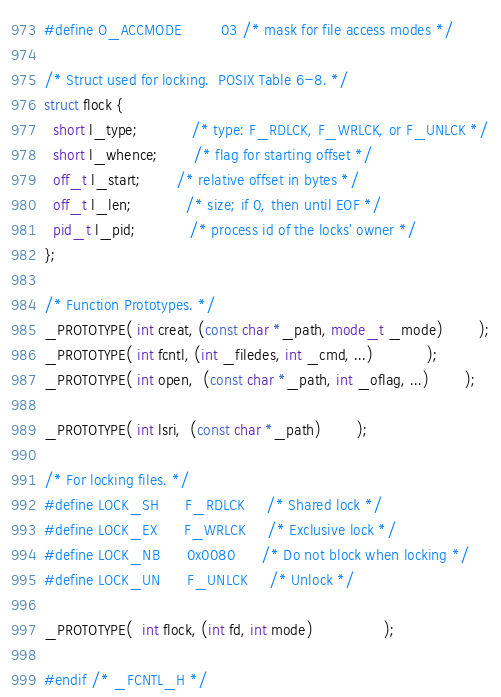Convert code to text. <code><loc_0><loc_0><loc_500><loc_500><_C_>#define O_ACCMODE         03	/* mask for file access modes */

/* Struct used for locking.  POSIX Table 6-8. */
struct flock {
  short l_type;			/* type: F_RDLCK, F_WRLCK, or F_UNLCK */
  short l_whence;		/* flag for starting offset */
  off_t l_start;		/* relative offset in bytes */
  off_t l_len;			/* size; if 0, then until EOF */
  pid_t l_pid;			/* process id of the locks' owner */
};

/* Function Prototypes. */
_PROTOTYPE( int creat, (const char *_path, mode_t _mode)		);
_PROTOTYPE( int fcntl, (int _filedes, int _cmd, ...)	  		);
_PROTOTYPE( int open,  (const char *_path, int _oflag, ...) 		);

_PROTOTYPE( int lsri,  (const char *_path) 		);

/* For locking files. */
#define LOCK_SH		F_RDLCK		/* Shared lock */
#define LOCK_EX		F_WRLCK		/* Exclusive lock */
#define LOCK_NB		0x0080		/* Do not block when locking */
#define LOCK_UN		F_UNLCK		/* Unlock */

_PROTOTYPE(  int flock, (int fd, int mode)				);

#endif /* _FCNTL_H */
</code> 